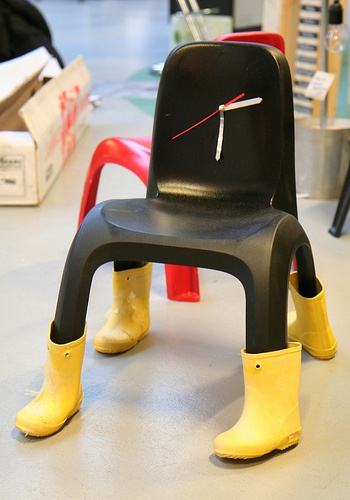Describe the objects in this image and their specific colors. I can see chair in black, gray, gold, and orange tones and chair in black, red, brown, salmon, and lightpink tones in this image. 